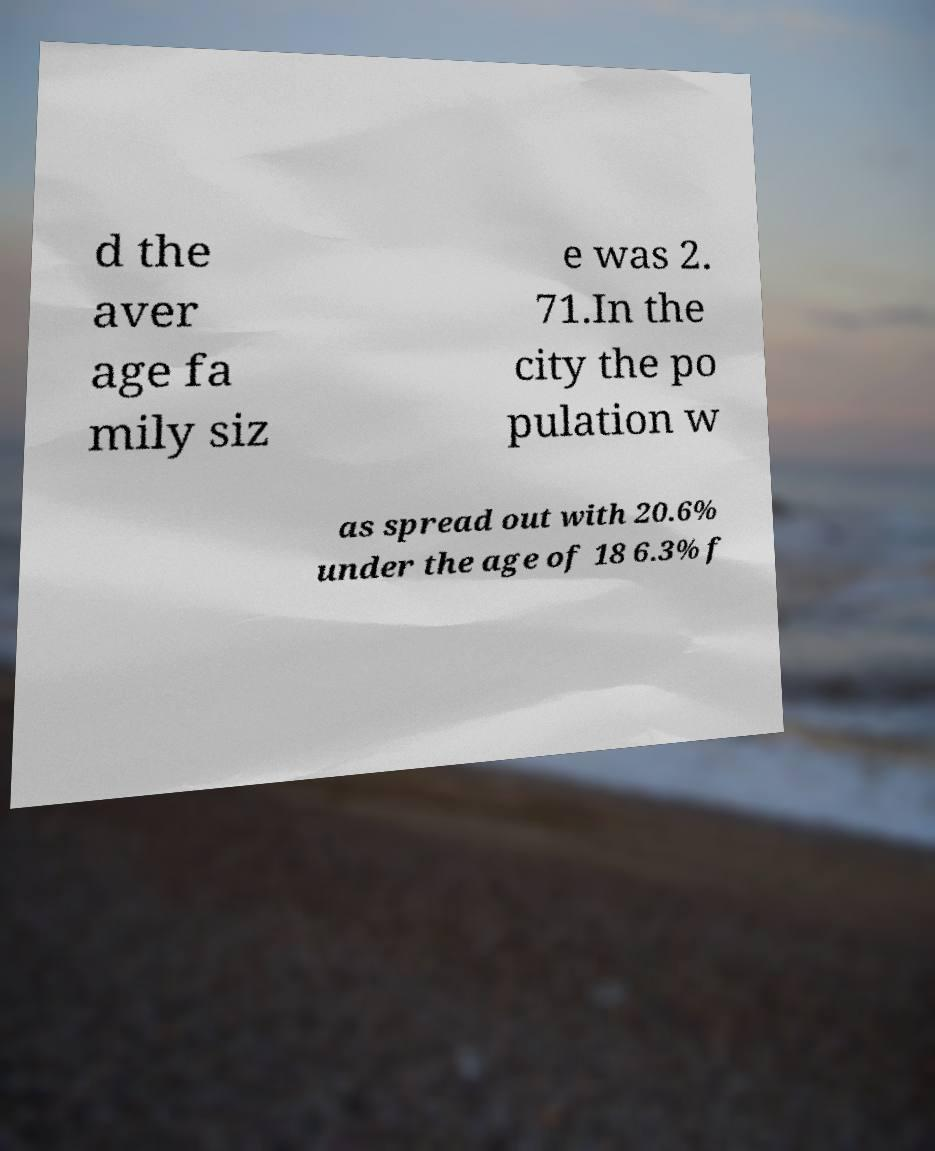What messages or text are displayed in this image? I need them in a readable, typed format. d the aver age fa mily siz e was 2. 71.In the city the po pulation w as spread out with 20.6% under the age of 18 6.3% f 